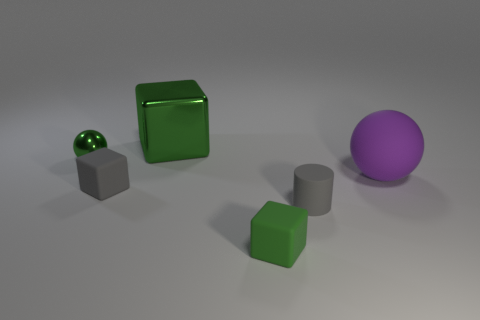What is the lighting source in the scene? Based on the shadows and highlights visible on the objects, there appears to be a single diffuse light source coming from above, slightly oriented to the right of the scene. This overhead positioning creates soft shadows beneath the objects, indicating the light is not overly harsh or direct. 